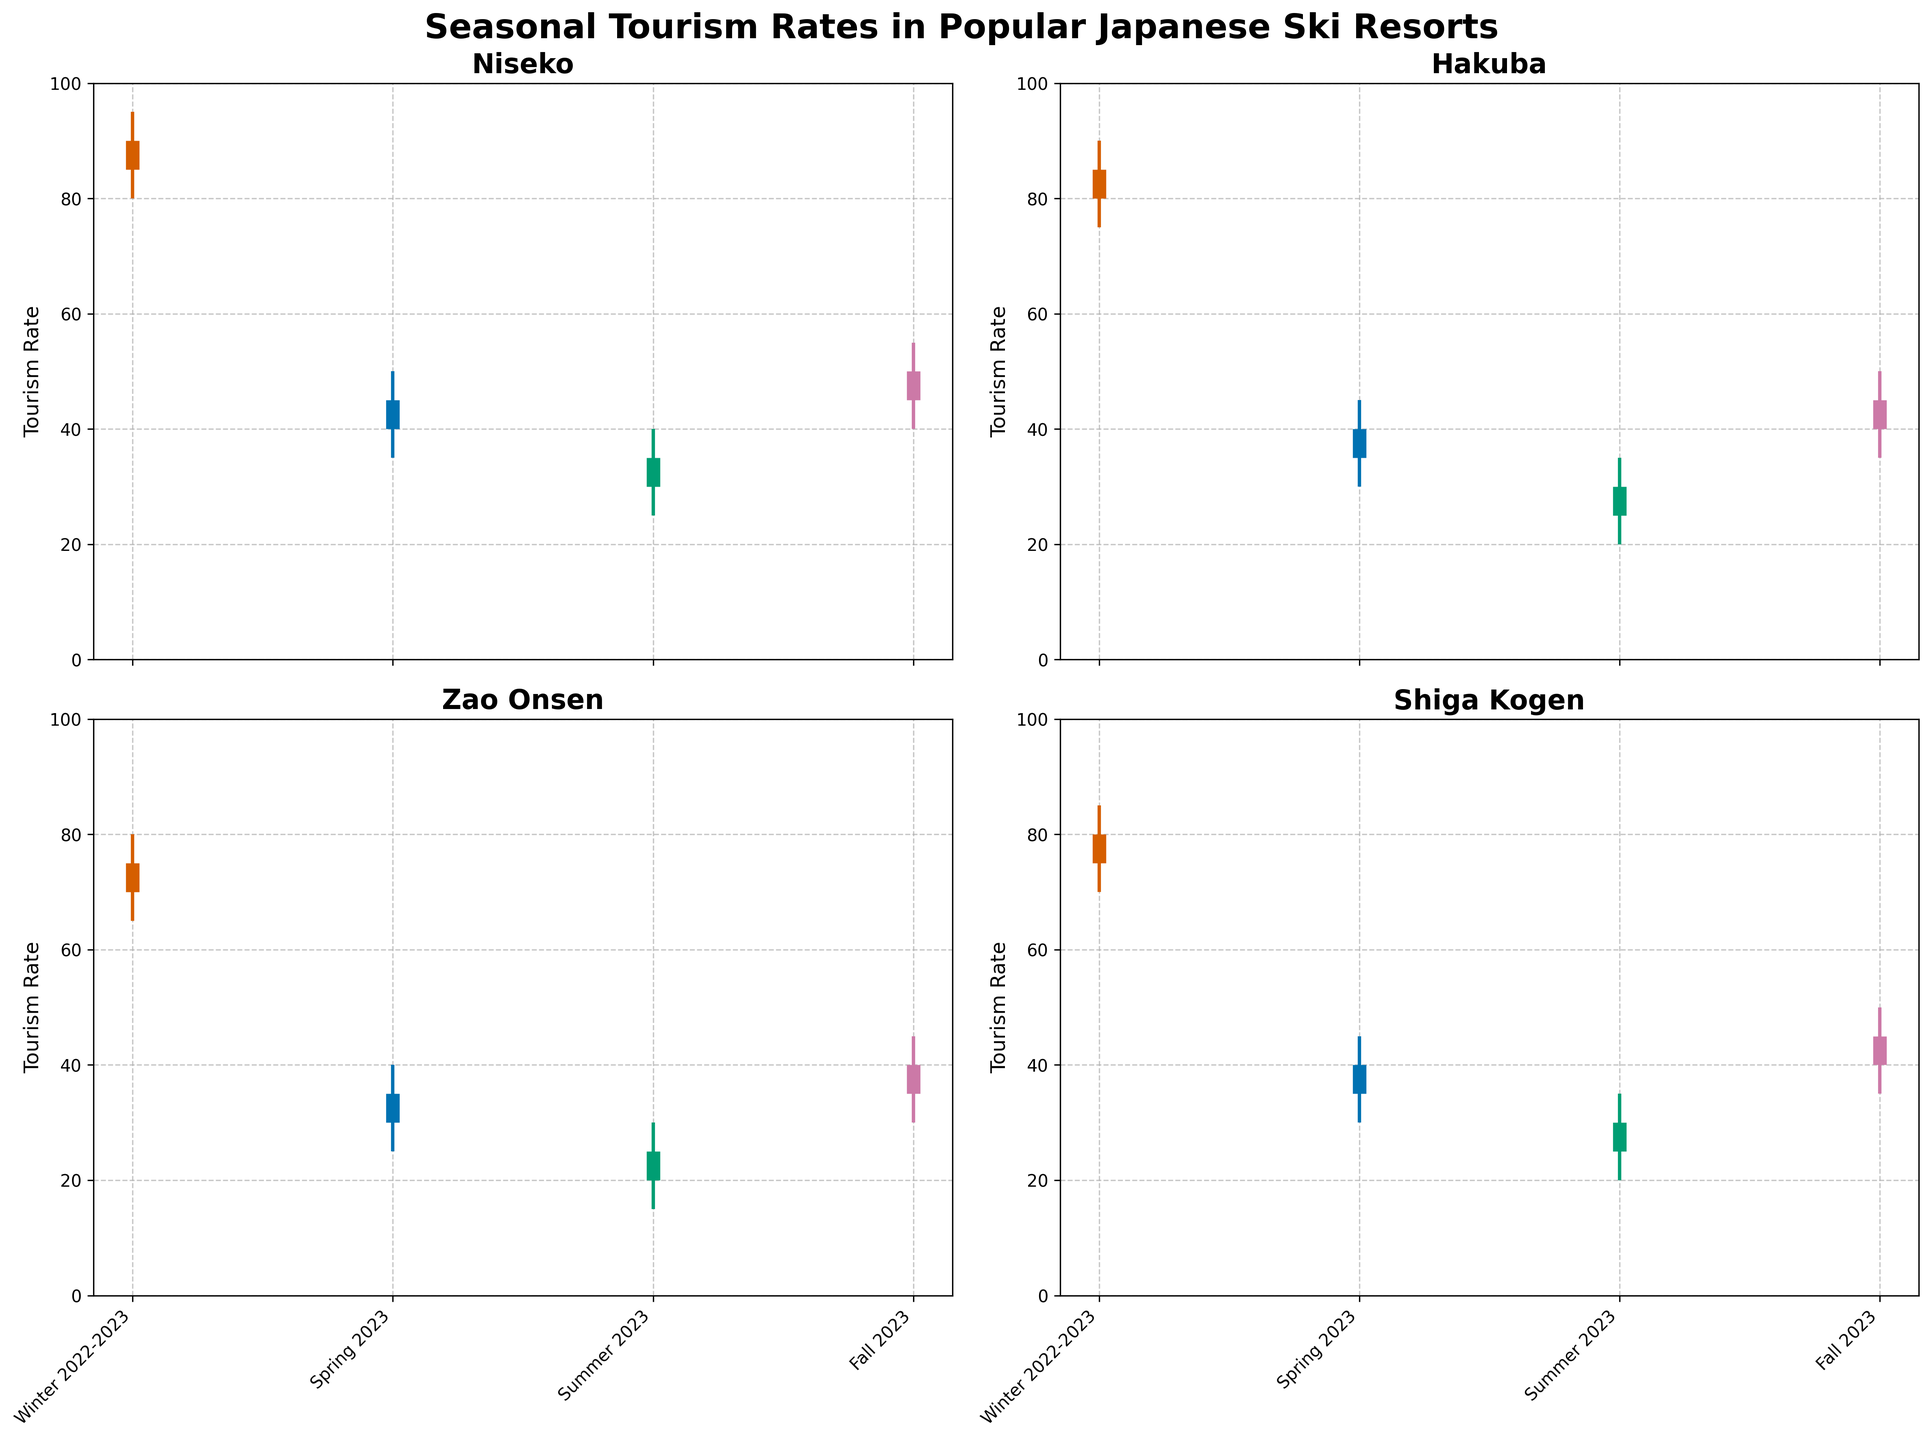Which resort has the highest tourism rate during the Winter 2022-2023 season? Look at the close values for the Winter 2022-2023 season for each resort. Niseko is 90, Hakuba is 85, Zao Onsen is 75, and Shiga Kogen is 80. Hence, Niseko has the highest tourism rate during Winter 2022-2023.
Answer: Niseko During which season does Hakuba have the lowest tourism rate? Look at the close values across all seasons for Hakuba. They are 85 for Winter 2022-2023, 40 for Spring 2023, 30 for Summer 2023, and 45 for Fall 2023. Summer 2023 is the lowest.
Answer: Summer 2023 What is the range of tourism rates in Zao Onsen during Summer 2023? The range can be found by subtracting the low value from the high value for Summer 2023 in Zao Onsen. The high value is 30 and the low value is 15, so the range is 30 - 15 = 15.
Answer: 15 Which season shows the highest variability in tourism rates for Shiga Kogen? Variability can be determined by the range (high - low values). For Shiga Kogen: Winter 2022-2023 has (85 - 70)=15, Spring 2023 has (45 - 30)=15, Summer 2023 has (35 - 20)=15, and Fall 2023 has (50 - 35)=15. All seasons show equal variability.
Answer: All seasons How does the tourism rate in Fall 2023 for Niseko compare to Spring 2023 in the same resort? Compare the close values for Niseko in Fall 2023 (50) and Spring 2023 (45). The Fall 2023 tourism rate is higher by 5 points.
Answer: Fall 2023 is higher by 5 points What's the average close value across all seasons for Hakuba? Add the close values for Hakuba across all seasons and divide by the number of seasons. (85+40+30+45)/4 = 50
Answer: 50 During which season do all resorts have the highest tourism rates? Compare the high values for each season across all resorts. Winter 2022-2023 values: Niseko 95, Hakuba 90, Zao Onsen 80, Shiga Kogen 85. Spring 2023 values: Niseko 50, Hakuba 45, Zao Onsen 40, Shiga Kogen 45. Summer 2023 values: Niseko 40, Hakuba 35, Zao Onsen 30, Shiga Kogen 35. Fall 2023 values: Niseko 55, Hakuba 50, Zao Onsen 45, Shiga Kogen 50. Winter 2022-2023 has the highest values overall.
Answer: Winter 2022-2023 From the data, which resort has the most consistent tourism rate across all seasons? Consistent tourism rates can be interpreted as smaller variations between high and low values across seasons. Calculate the difference for each resort and take the average of those differences. Compare these averages for each resort. Zao Onsen shows a lower overall variability [(80-65)+(40-25)+(30-15)+(45-30)]/4 = 15 compared to the others.
Answer: Zao Onsen Is there a season where the tourism rate was lower than expected for a popular resort? Compare the close values of each season and identify a potentially unexpected low value. Niseko's Summer 2023 close value (35) is significantly lower compared to other seasons for this resort.
Answer: Niseko Summer 2023 In which seasons do Hakuba and Shiga Kogen have the same close values? Look for matching close values between Hakuba and Shiga Kogen. Both have a close value of 40 in Spring 2023.
Answer: Spring 2023 